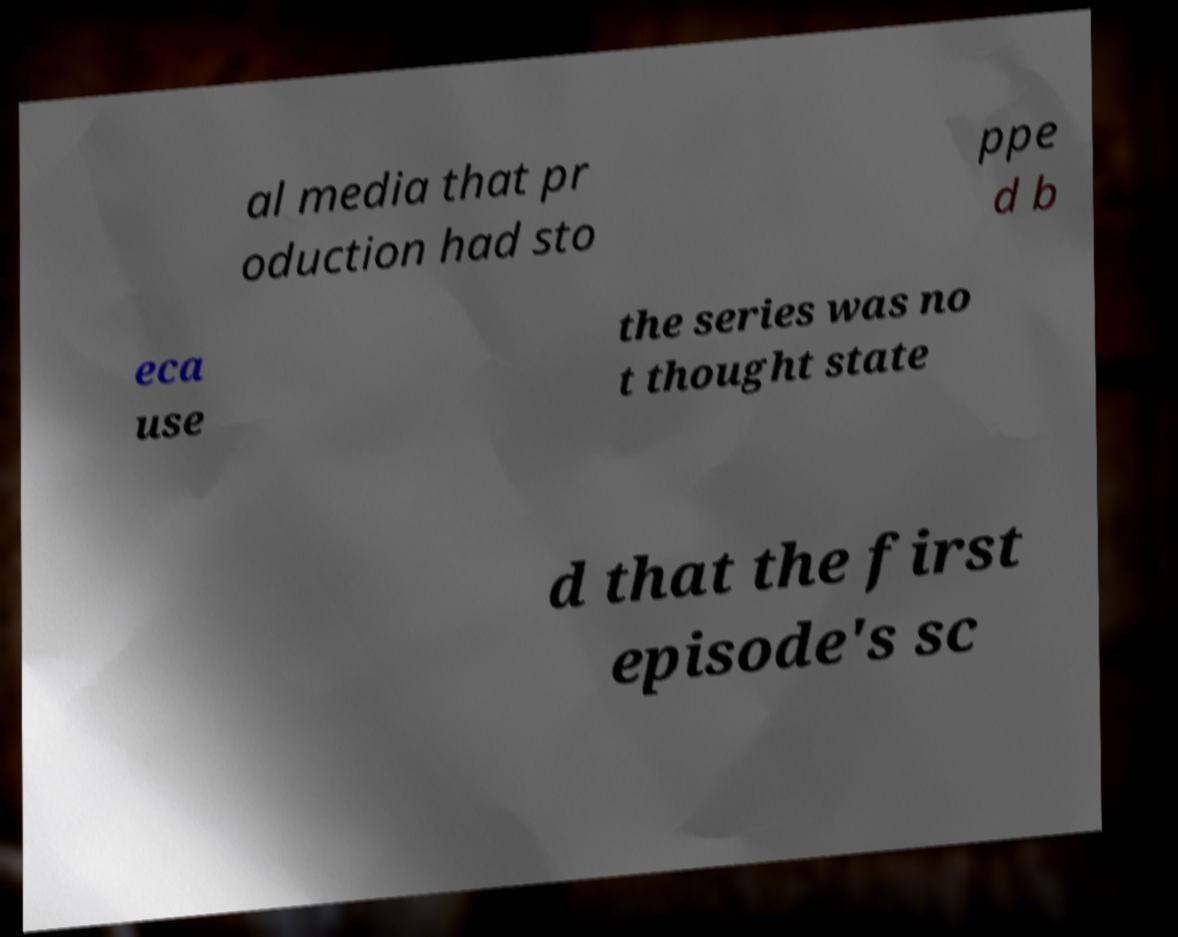Can you accurately transcribe the text from the provided image for me? al media that pr oduction had sto ppe d b eca use the series was no t thought state d that the first episode's sc 